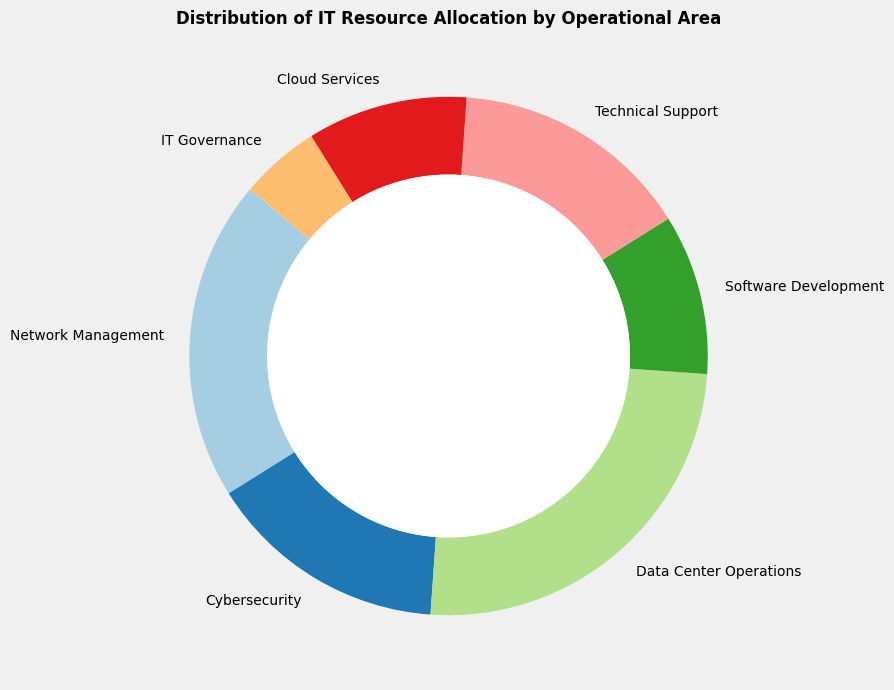What percentage of IT resources is allocated to the least prioritized operational area? By examining the ring chart, we identify the operational area with the smallest percentage listed. IT Governance has a 5% allocation, which is the lowest.
Answer: 5% What is the total percentage of IT resources allocated to Software Development and Cloud Services? Adding the percentages allocated to Software Development (10%) and Cloud Services (10%) gives 10% + 10% = 20%.
Answer: 20% How much more is allocated to Data Center Operations compared to IT Governance? By subtracting the percentage allocated to IT Governance (5%) from Data Center Operations (25%), we find 25% - 5% = 20%.
Answer: 20% Which operational area has the highest allocation of IT resources? The ring chart shows that Data Center Operations has the highest allocation at 25%.
Answer: Data Center Operations Is the allocation to Network Management greater than that to Cybersecurity? Comparing the percentages, Network Management has 20% while Cybersecurity has 15%, so Network Management has a greater allocation.
Answer: Yes What is the average allocation percentage across all operational areas? Summing all the percentages and then dividing by the number of areas: (20 + 15 + 25 + 10 + 15 + 10 + 5) / 7 = 100 / 7 ≈ 14.3%.
Answer: 14.3% What is the difference in allocation between Technical Support and Cloud Services? Subtracting the Cloud Services percentage (10%) from Technical Support (15%) gives 15% - 10% = 5%.
Answer: 5% Is the overall allocation higher for network-related areas (Network Management, Cybersecurity) or for service-related areas (Cloud Services, Technical Support)? Adding the percentages for network-related areas (Network Management 20% + Cybersecurity 15% = 35%) and for service-related areas (Cloud Services 10% + Technical Support 15% = 25%), network-related areas have a higher allocation.
Answer: Network-related areas What percentage of total IT resources is dedicated to operational areas other than Data Center Operations? Subtracting the Data Center Operations allocation from the total, we get 100% - 25% = 75%.
Answer: 75% Which operational area represents 10% of the allocation and appears twice in the chart? Checking the ring chart, both Software Development and Cloud Services have an allocation of 10%.
Answer: Software Development and Cloud Services 